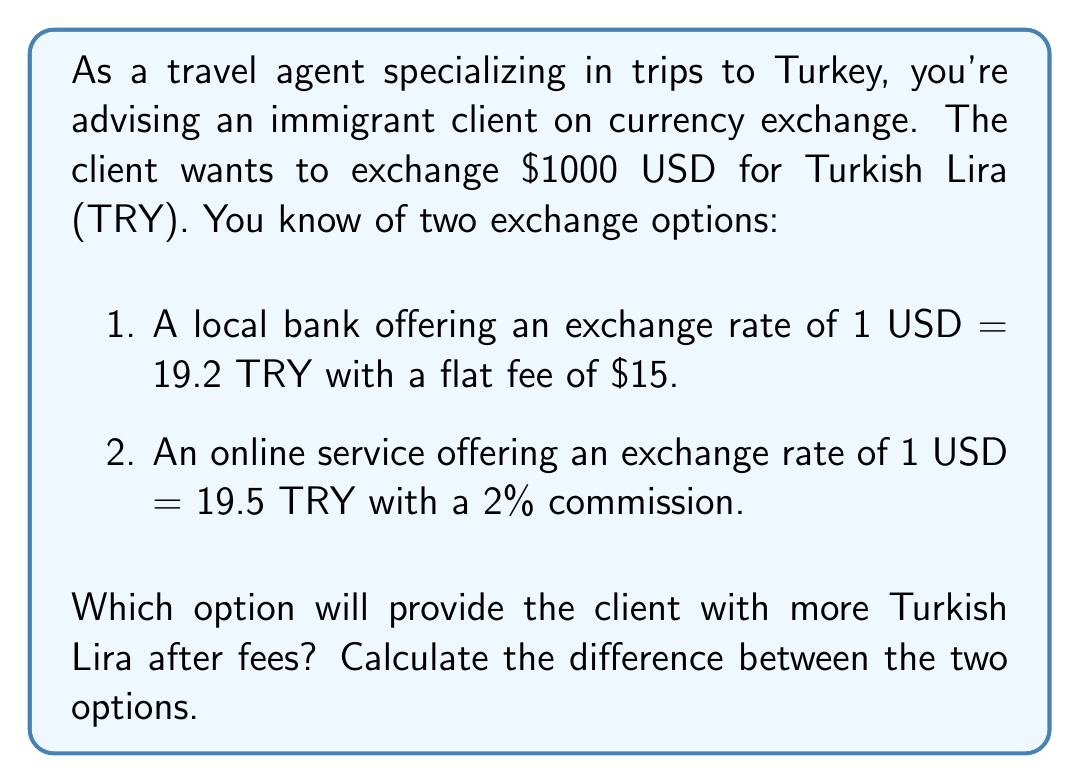Solve this math problem. Let's solve this problem step by step:

1. Calculate the amount of TRY received from the local bank:
   $$1000 \text{ USD} \times 19.2 \text{ TRY/USD} = 19200 \text{ TRY}$$
   Subtract the flat fee:
   $$19200 \text{ TRY} - (15 \text{ USD} \times 19.2 \text{ TRY/USD}) = 19200 \text{ TRY} - 288 \text{ TRY} = 18912 \text{ TRY}$$

2. Calculate the amount of TRY received from the online service:
   $$1000 \text{ USD} \times 19.5 \text{ TRY/USD} = 19500 \text{ TRY}$$
   Calculate the 2% commission:
   $$19500 \text{ TRY} \times 0.02 = 390 \text{ TRY}$$
   Subtract the commission:
   $$19500 \text{ TRY} - 390 \text{ TRY} = 19110 \text{ TRY}$$

3. Calculate the difference between the two options:
   $$19110 \text{ TRY} - 18912 \text{ TRY} = 198 \text{ TRY}$$
Answer: The online service provides 198 TRY more than the local bank, making it the better option for the client. 